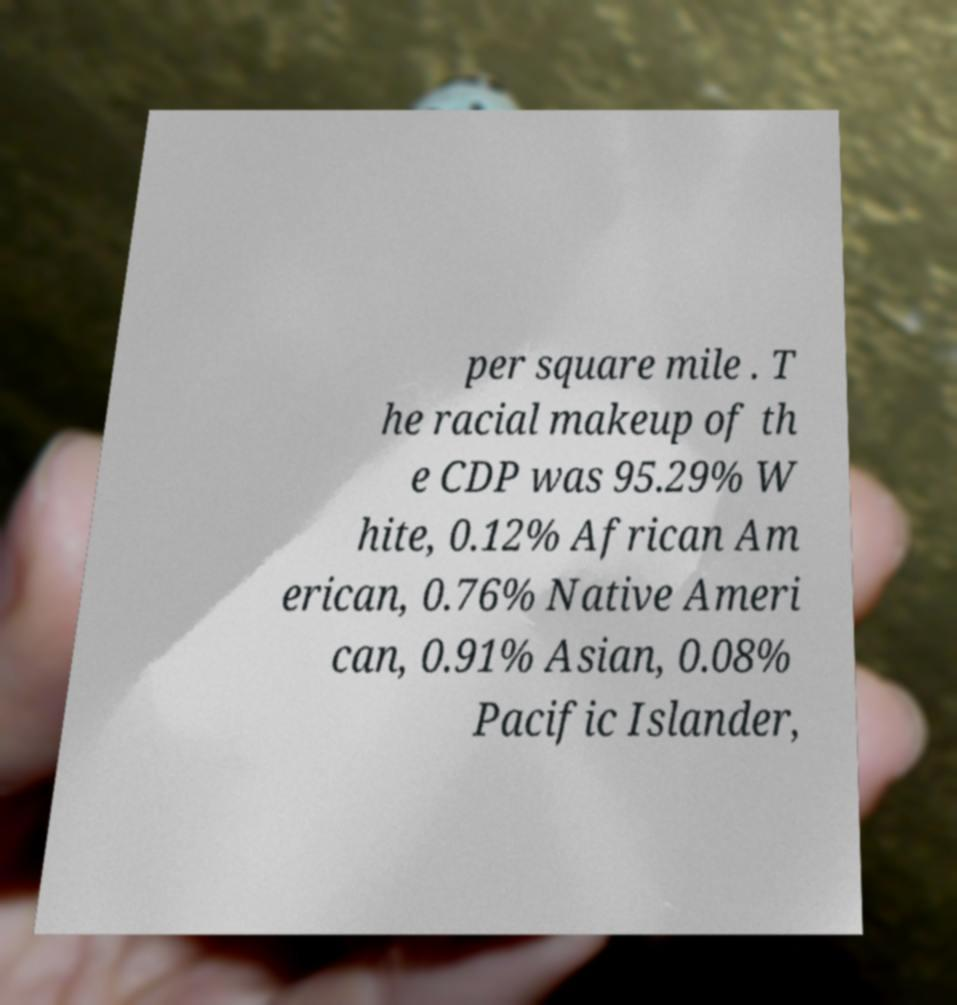Can you accurately transcribe the text from the provided image for me? per square mile . T he racial makeup of th e CDP was 95.29% W hite, 0.12% African Am erican, 0.76% Native Ameri can, 0.91% Asian, 0.08% Pacific Islander, 